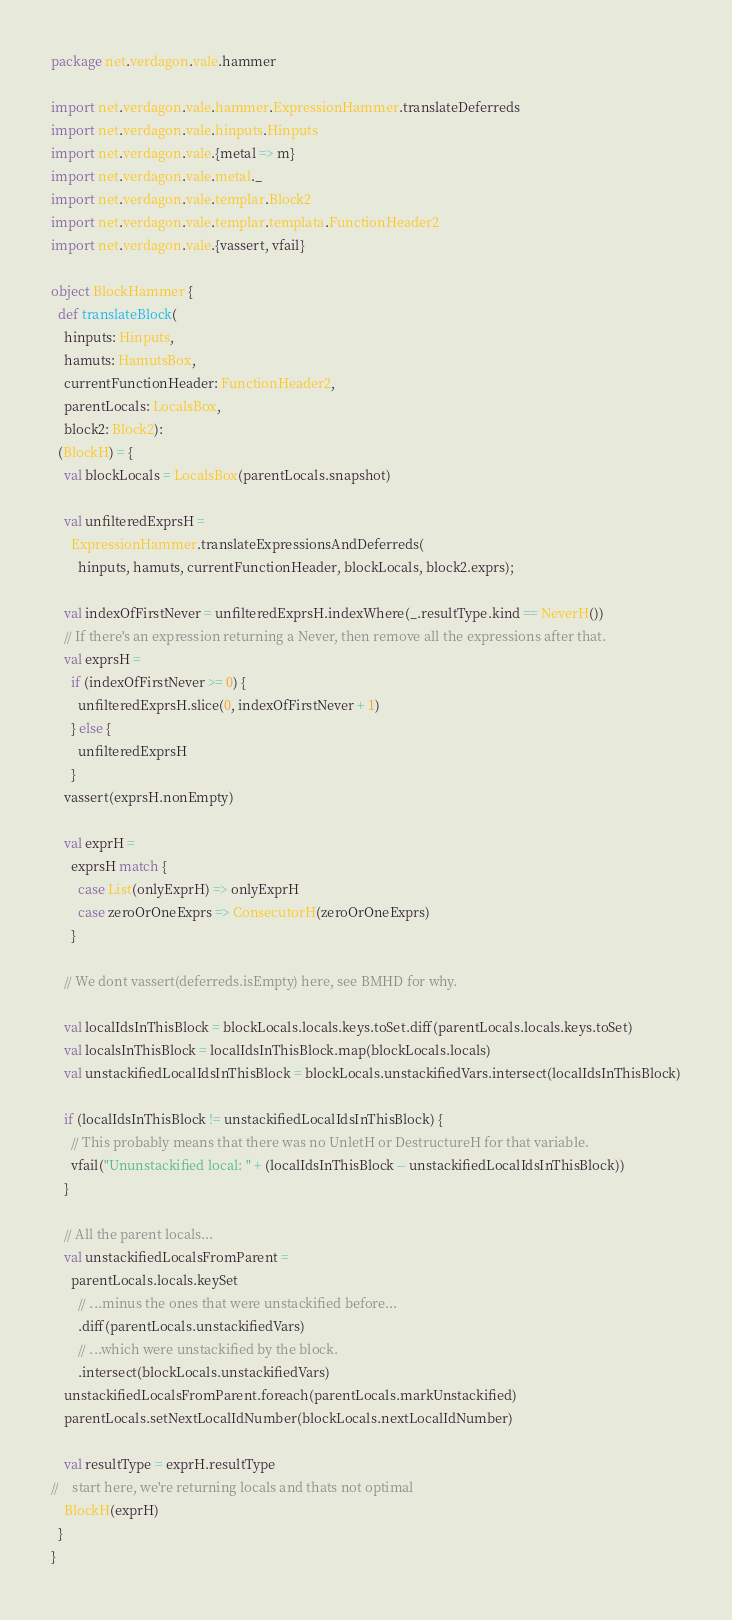Convert code to text. <code><loc_0><loc_0><loc_500><loc_500><_Scala_>package net.verdagon.vale.hammer

import net.verdagon.vale.hammer.ExpressionHammer.translateDeferreds
import net.verdagon.vale.hinputs.Hinputs
import net.verdagon.vale.{metal => m}
import net.verdagon.vale.metal._
import net.verdagon.vale.templar.Block2
import net.verdagon.vale.templar.templata.FunctionHeader2
import net.verdagon.vale.{vassert, vfail}

object BlockHammer {
  def translateBlock(
    hinputs: Hinputs,
    hamuts: HamutsBox,
    currentFunctionHeader: FunctionHeader2,
    parentLocals: LocalsBox,
    block2: Block2):
  (BlockH) = {
    val blockLocals = LocalsBox(parentLocals.snapshot)

    val unfilteredExprsH =
      ExpressionHammer.translateExpressionsAndDeferreds(
        hinputs, hamuts, currentFunctionHeader, blockLocals, block2.exprs);

    val indexOfFirstNever = unfilteredExprsH.indexWhere(_.resultType.kind == NeverH())
    // If there's an expression returning a Never, then remove all the expressions after that.
    val exprsH =
      if (indexOfFirstNever >= 0) {
        unfilteredExprsH.slice(0, indexOfFirstNever + 1)
      } else {
        unfilteredExprsH
      }
    vassert(exprsH.nonEmpty)

    val exprH =
      exprsH match {
        case List(onlyExprH) => onlyExprH
        case zeroOrOneExprs => ConsecutorH(zeroOrOneExprs)
      }

    // We dont vassert(deferreds.isEmpty) here, see BMHD for why.

    val localIdsInThisBlock = blockLocals.locals.keys.toSet.diff(parentLocals.locals.keys.toSet)
    val localsInThisBlock = localIdsInThisBlock.map(blockLocals.locals)
    val unstackifiedLocalIdsInThisBlock = blockLocals.unstackifiedVars.intersect(localIdsInThisBlock)

    if (localIdsInThisBlock != unstackifiedLocalIdsInThisBlock) {
      // This probably means that there was no UnletH or DestructureH for that variable.
      vfail("Ununstackified local: " + (localIdsInThisBlock -- unstackifiedLocalIdsInThisBlock))
    }

    // All the parent locals...
    val unstackifiedLocalsFromParent =
      parentLocals.locals.keySet
        // ...minus the ones that were unstackified before...
        .diff(parentLocals.unstackifiedVars)
        // ...which were unstackified by the block.
        .intersect(blockLocals.unstackifiedVars)
    unstackifiedLocalsFromParent.foreach(parentLocals.markUnstackified)
    parentLocals.setNextLocalIdNumber(blockLocals.nextLocalIdNumber)

    val resultType = exprH.resultType
//    start here, we're returning locals and thats not optimal
    BlockH(exprH)
  }
}
</code> 